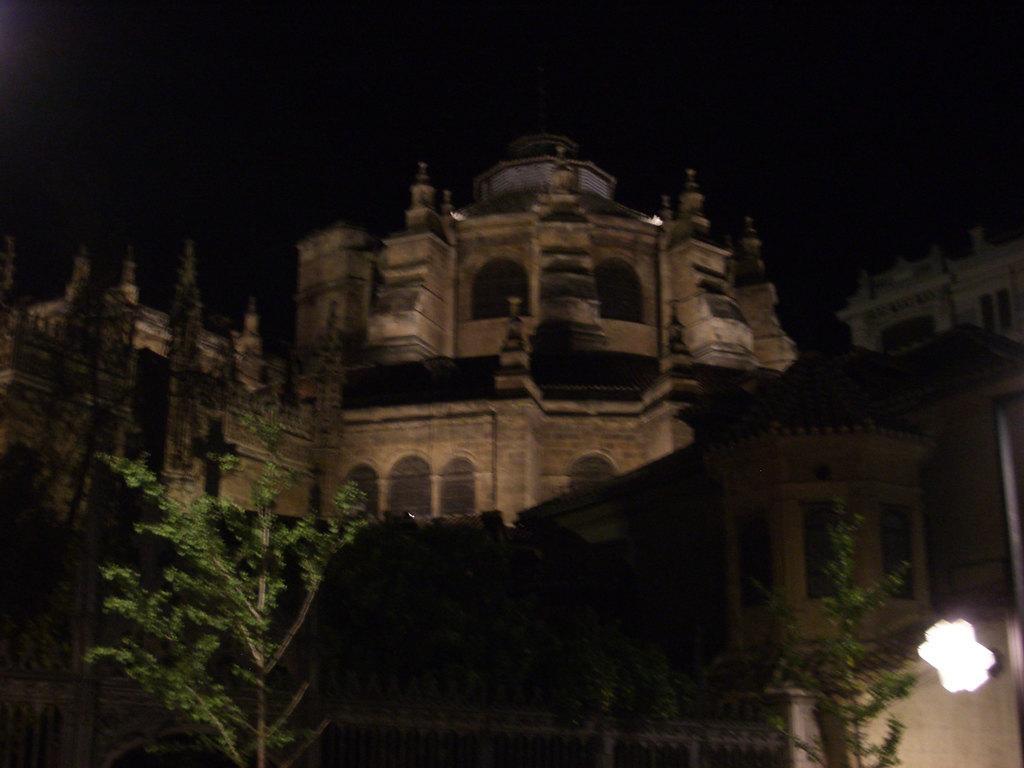In one or two sentences, can you explain what this image depicts? In this image there is a building at top of this image and there are some trees in middle of this image and there is one fencing gate at bottom of this image. 